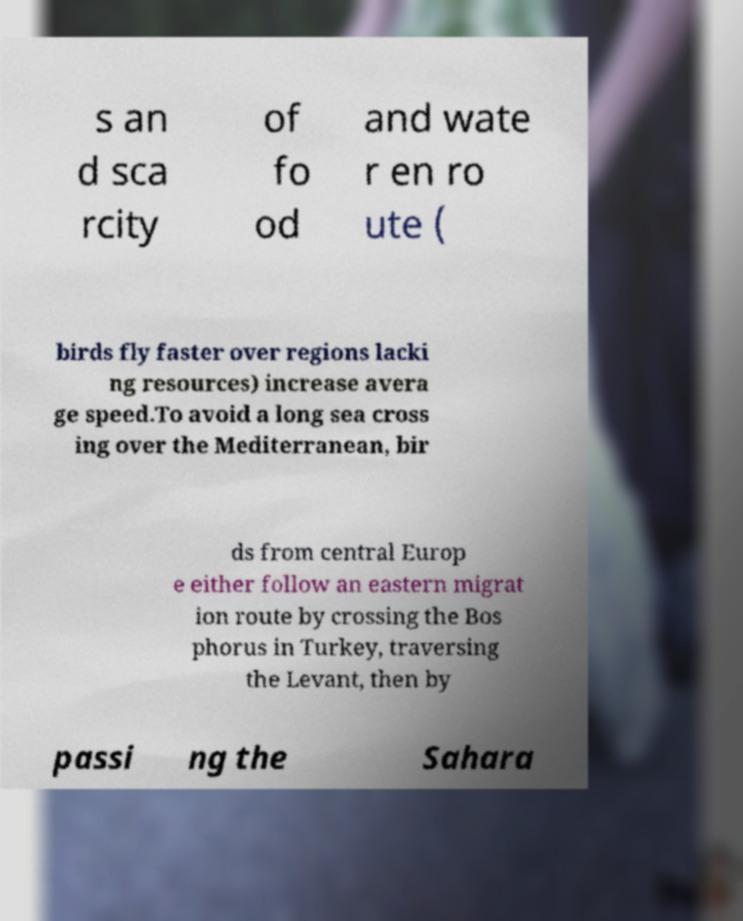Could you assist in decoding the text presented in this image and type it out clearly? s an d sca rcity of fo od and wate r en ro ute ( birds fly faster over regions lacki ng resources) increase avera ge speed.To avoid a long sea cross ing over the Mediterranean, bir ds from central Europ e either follow an eastern migrat ion route by crossing the Bos phorus in Turkey, traversing the Levant, then by passi ng the Sahara 